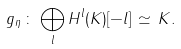<formula> <loc_0><loc_0><loc_500><loc_500>g _ { \eta } \, \colon \, \bigoplus _ { l } H ^ { l } ( K ) [ - l ] \, \simeq \, K .</formula> 